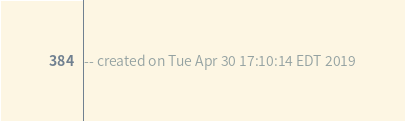Convert code to text. <code><loc_0><loc_0><loc_500><loc_500><_SQL_>-- created on Tue Apr 30 17:10:14 EDT 2019
</code> 